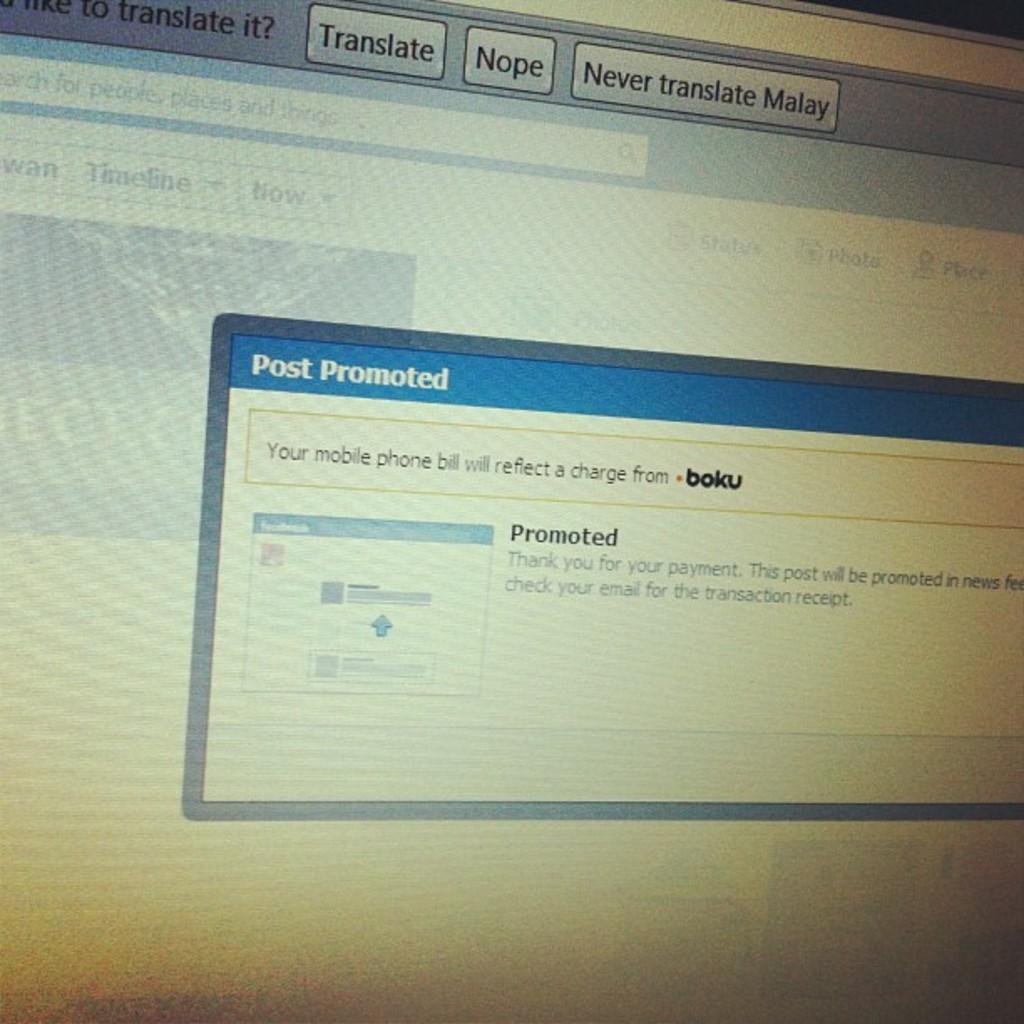What is the heading of the text box in blue?
Your response must be concise. Post promoted. What will your mobile phone bill reflect a charge from according to the window?
Provide a succinct answer. Boku. 